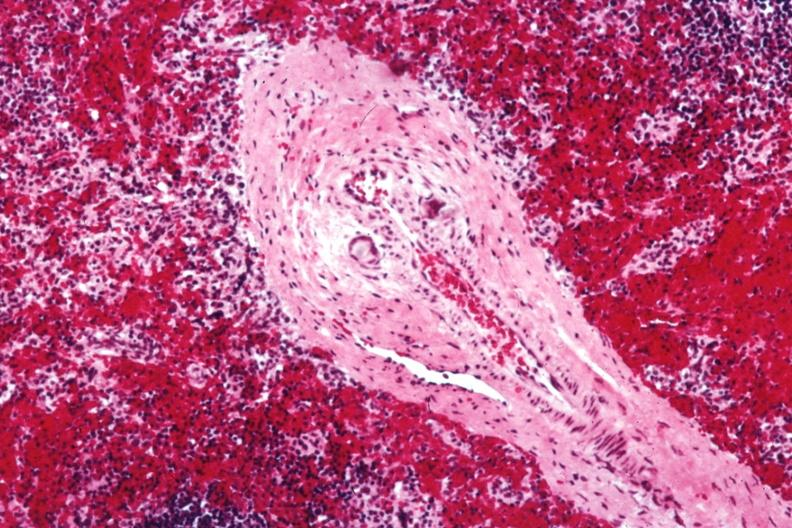what thought to be silicon?
Answer the question using a single word or phrase. Postoperative cardiac surgery 